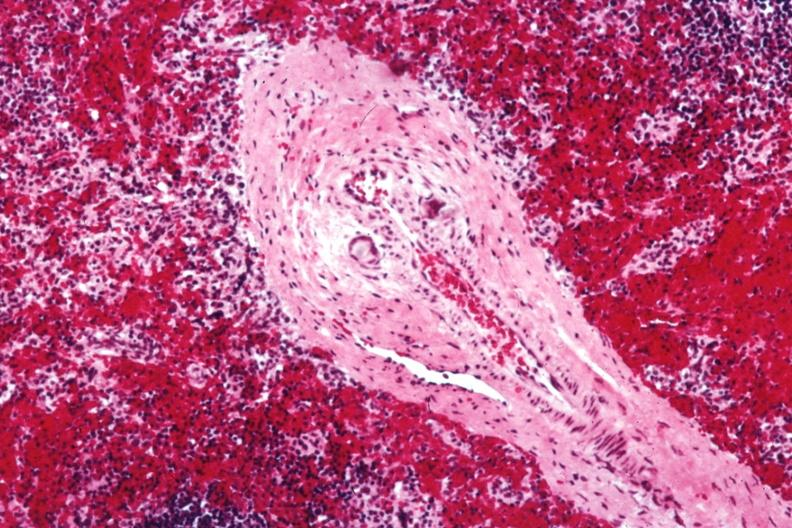what thought to be silicon?
Answer the question using a single word or phrase. Postoperative cardiac surgery 